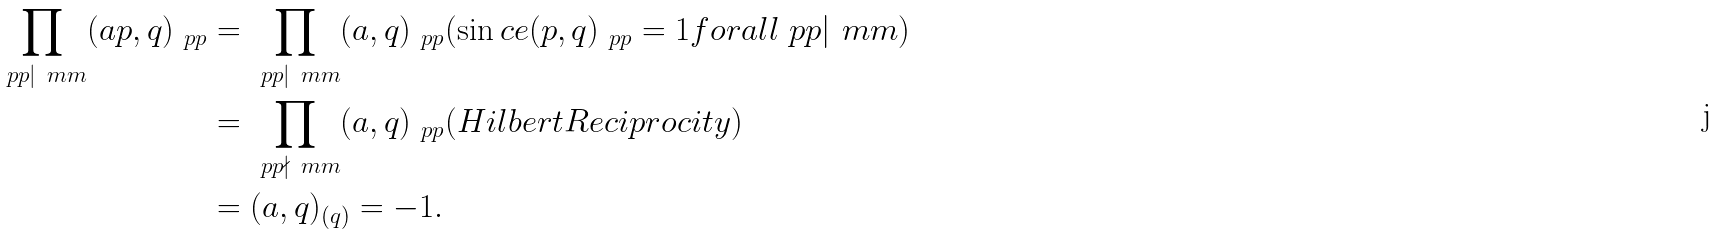<formula> <loc_0><loc_0><loc_500><loc_500>\prod _ { \ p p | \ m m } ( a p , q ) _ { \ p p } & = \prod _ { \ p p | \ m m } ( a , q ) _ { \ p p } ( \sin c e ( p , q ) _ { \ p p } = 1 f o r a l l \ p p | \ m m ) \\ & = \prod _ { \ p p \nmid \ m m } ( a , q ) _ { \ p p } ( H i l b e r t R e c i p r o c i t y ) \\ & = ( a , q ) _ { ( q ) } = - 1 .</formula> 